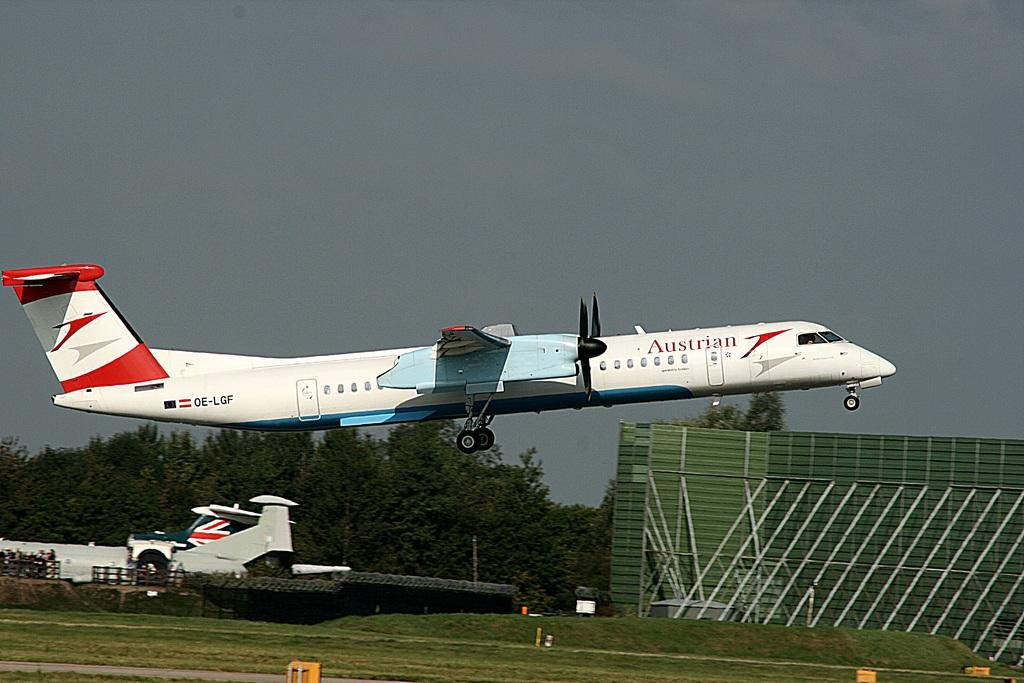What type of vegetation is present in the image? There is grass in the image. What can be seen flying in the air in the image? There is an airplane flying in the air in the image. What type of barrier is visible in the image? There is a fence in the image. What other natural elements are present in the image? There are trees in the image. What type of structure is visible in the image? There is a wall in the image. How would you describe the sky in the background of the image? The sky in the background of the image is cloudy. Where is the wound located on the airplane in the image? There is no wound present on the airplane in the image; it is flying without any visible damage. 